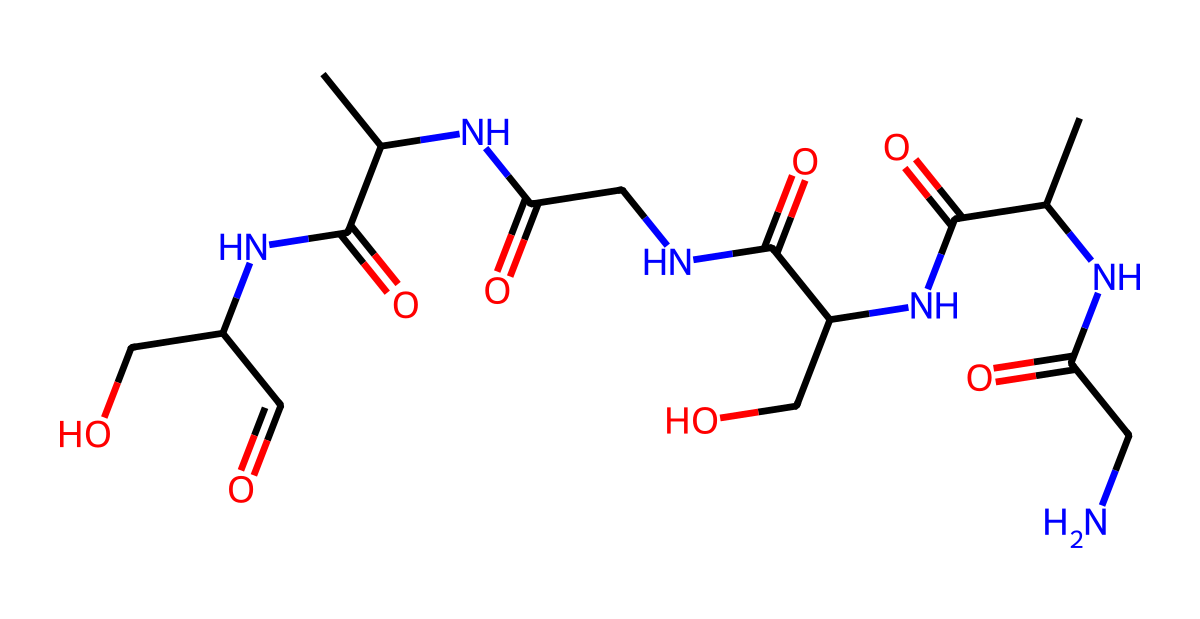What is the primary functional group in this structure? The structure contains multiple amide groups indicated by the presence of -C(=O)N- linkages, which are characteristic of proteins and fibers.
Answer: amide How many nitrogen atoms are present? Counting the nitrogen atoms in the structure, there are six nitrogen atoms present.
Answer: six What type of bond connects the amino acid residues in this fiber? The connections between the amino acid residues are formed by peptide bonds, which are the result of amide linkages.
Answer: peptide What is the total number of carbon atoms in this molecule? By analyzing the structure, we identify a total of 12 carbon atoms present in the entire molecule.
Answer: twelve Does this structure suggest that the fiber is hydrophilic or hydrophobic? Given the presence of hydroxyl (-OH) groups in the structure, which can form hydrogen bonds with water, this suggests the fiber is hydrophilic.
Answer: hydrophilic What biological function is primarily supported by this type of fiber? This type of fiber, like spider silk, is primarily used for web construction, a critical function for trapping prey and providing shelter.
Answer: web construction 